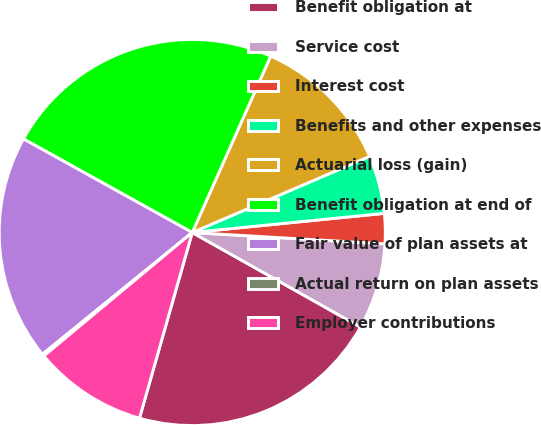<chart> <loc_0><loc_0><loc_500><loc_500><pie_chart><fcel>Benefit obligation at<fcel>Service cost<fcel>Interest cost<fcel>Benefits and other expenses<fcel>Actuarial loss (gain)<fcel>Benefit obligation at end of<fcel>Fair value of plan assets at<fcel>Actual return on plan assets<fcel>Employer contributions<nl><fcel>21.26%<fcel>7.21%<fcel>2.52%<fcel>4.87%<fcel>11.89%<fcel>23.6%<fcel>18.92%<fcel>0.18%<fcel>9.55%<nl></chart> 